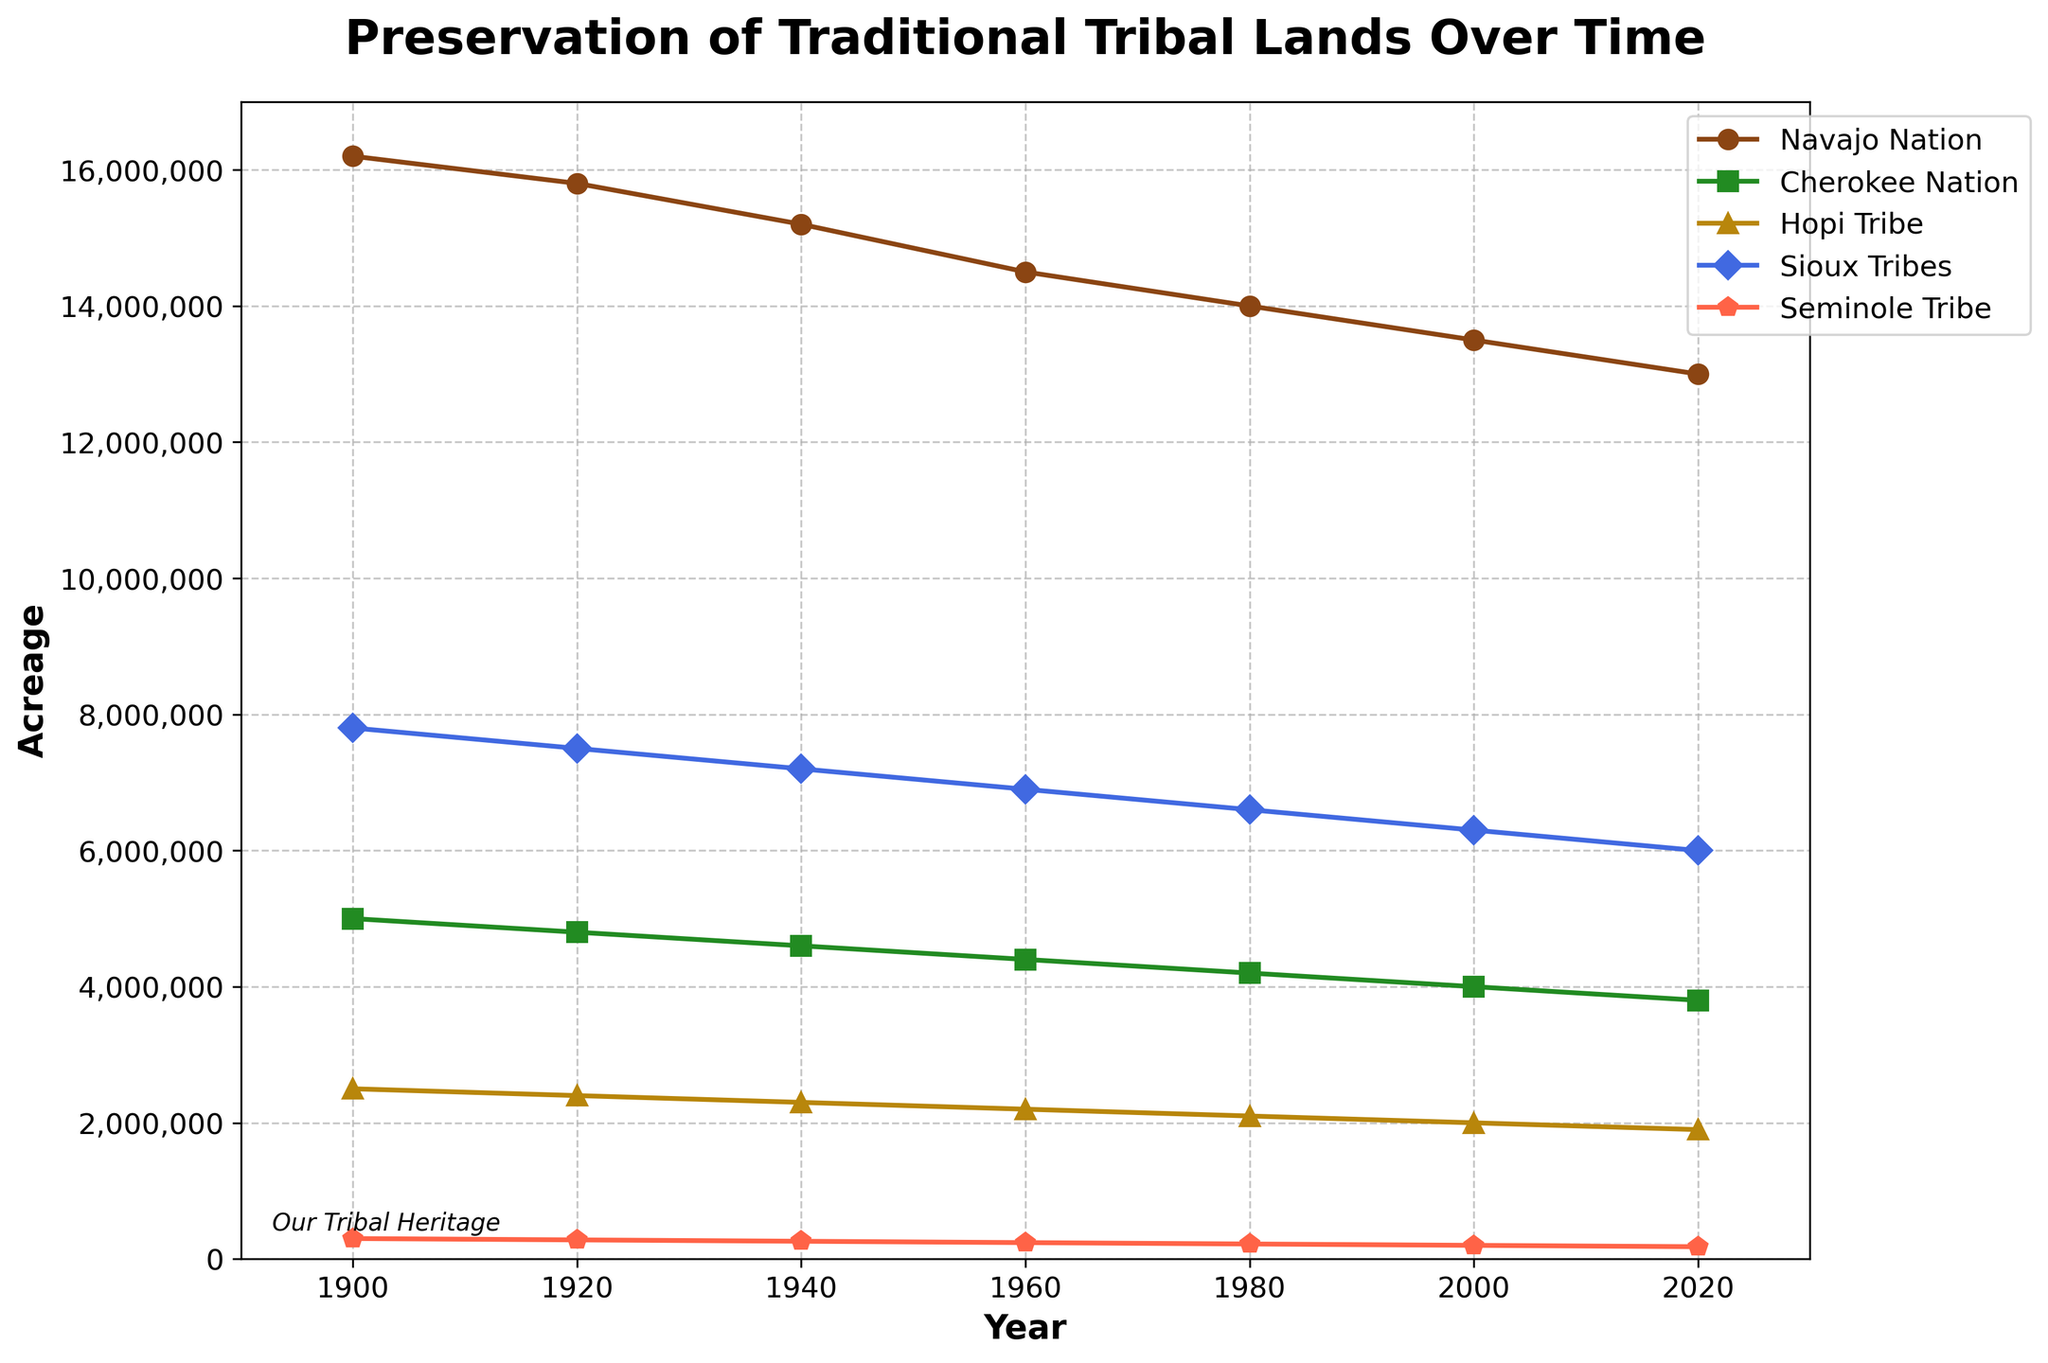What's the range of land acreage for the Navajo Nation from 1900 to 2020? The acreage of the Navajo Nation in 1900 was 16,200,000 and in 2020 it was 13,000,000. The range is 16,200,000 - 13,000,000 = 3,200,000.
Answer: 3,200,000 Which tribe experienced the largest decrease in land acreage over time? To determine which tribe experienced the largest decrease, we subtract the acreage in 2020 from the acreage in 1900 for each tribe. The decreases are: Navajo Nation: 16,200,000 - 13,000,000 = 3,200,000; Cherokee Nation: 5,000,000 - 3,800,000 = 1,200,000; Hopi Tribe: 2,500,000 - 1,900,000 = 600,000; Sioux Tribes: 7,800,000 - 6,000,000 = 1,800,000; Seminole Tribe: 300,000 - 180,000 = 120,000. The Navajo Nation experienced the largest decrease.
Answer: Navajo Nation Which tribe had the smallest land area in 2020? By looking at the final data points for each tribe in 2020, the acreages are: Navajo Nation: 13,000,000; Cherokee Nation: 3,800,000; Hopi Tribe: 1,900,000; Sioux Tribes: 6,000,000; Seminole Tribe: 180,000. The Seminole Tribe had the smallest land area.
Answer: Seminole Tribe Between which years did the Sioux Tribes' land acreage decrease the most? By examining the decreases between consecutive years for the Sioux Tribes: 1900 to 1920: 7,800,000 - 7,500,000 = 300,000; 1920 to 1940: 7,500,000 - 7,200,000 = 300,000; 1940 to 1960: 7,200,000 - 6,900,000 = 300,000; 1960 to 1980: 6,900,000 - 6,600,000 = 300,000; 1980 to 2000: 6,600,000 - 6,300,000 = 300,000; 2000 to 2020: 6,300,000 - 6,000,000 = 300,000. The decreases are all the same, 300,000 acres, so all time intervals tied.
Answer: 1900-1920, 1920-1940, 1940-1960, 1960-1980, 1980-2000, 2000-2020 On average, what was the land acreage of the Hopi Tribe every decade from 1900 to 2020? First, find the acreage for each specified year. The values are 2,500,000 (1900), 2,400,000 (1920), 2,300,000 (1940), 2,200,000 (1960), 2,100,000 (1980), 2,000,000 (2000), 1,900,000 (2020). The sum is 15,400,000 and there are 7 decades. Average = 15,400,000 / 7 = 2,200,000.
Answer: 2,200,000 What was the difference in acreage between the Cherokee Nation and the Hopi Tribe in 1960? In 1960, the Cherokee Nation had 4,400,000 acres and the Hopi Tribe had 2,200,000 acres. The difference is 4,400,000 - 2,200,000 = 2,200,000.
Answer: 2,200,000 